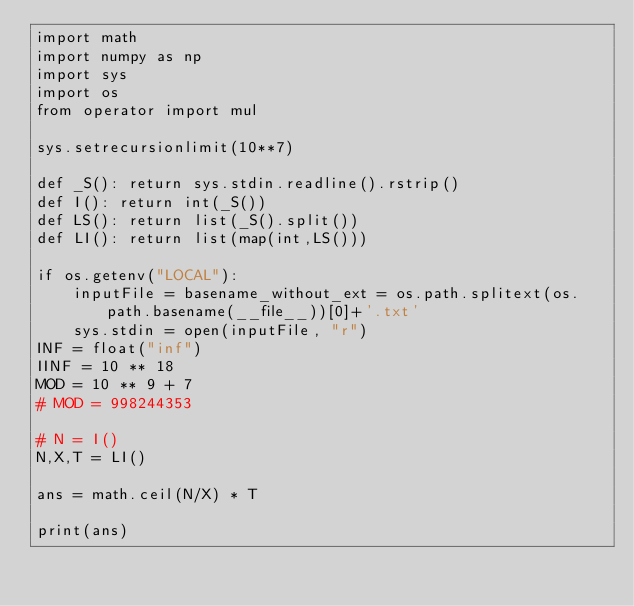<code> <loc_0><loc_0><loc_500><loc_500><_Python_>import math
import numpy as np
import sys
import os
from operator import mul

sys.setrecursionlimit(10**7)

def _S(): return sys.stdin.readline().rstrip()
def I(): return int(_S())
def LS(): return list(_S().split())
def LI(): return list(map(int,LS()))

if os.getenv("LOCAL"):
    inputFile = basename_without_ext = os.path.splitext(os.path.basename(__file__))[0]+'.txt'
    sys.stdin = open(inputFile, "r")
INF = float("inf")
IINF = 10 ** 18
MOD = 10 ** 9 + 7
# MOD = 998244353    

# N = I()
N,X,T = LI()

ans = math.ceil(N/X) * T

print(ans)</code> 